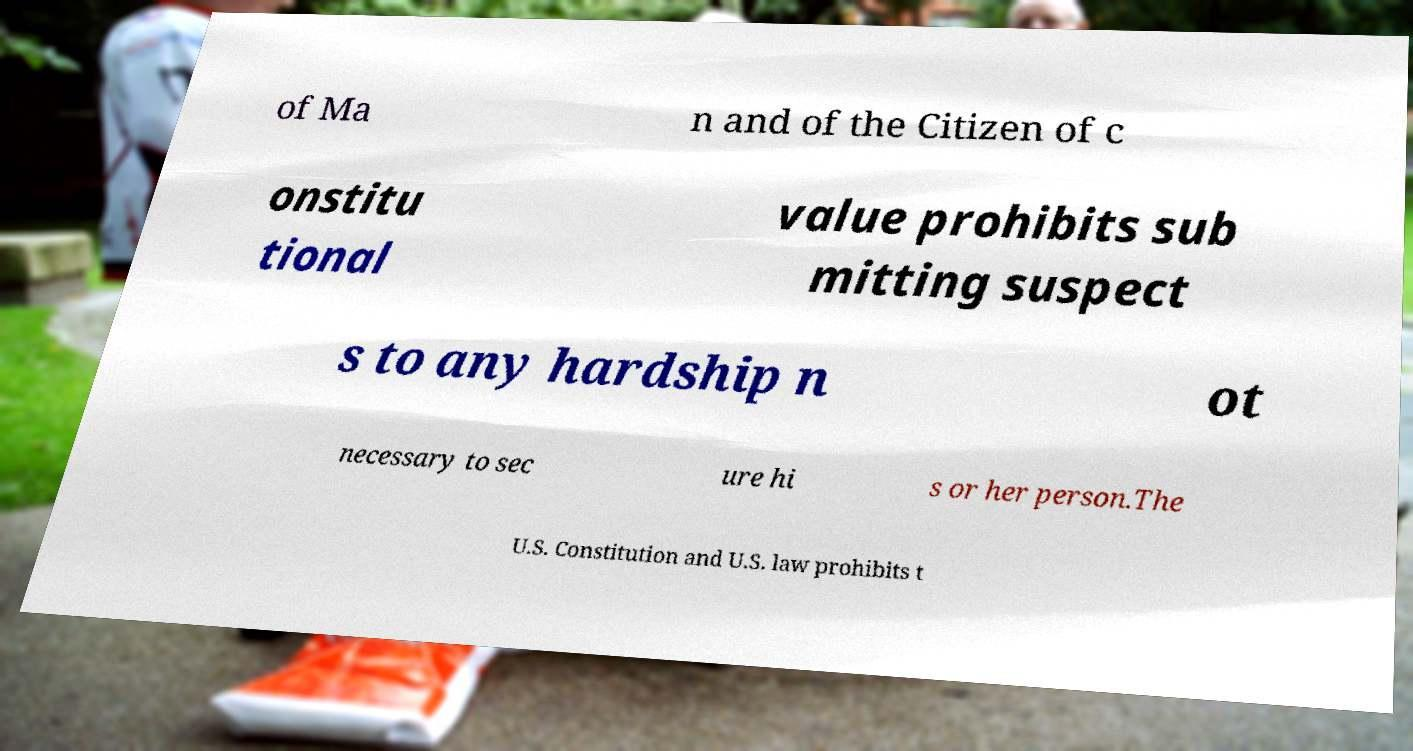Can you read and provide the text displayed in the image?This photo seems to have some interesting text. Can you extract and type it out for me? of Ma n and of the Citizen of c onstitu tional value prohibits sub mitting suspect s to any hardship n ot necessary to sec ure hi s or her person.The U.S. Constitution and U.S. law prohibits t 